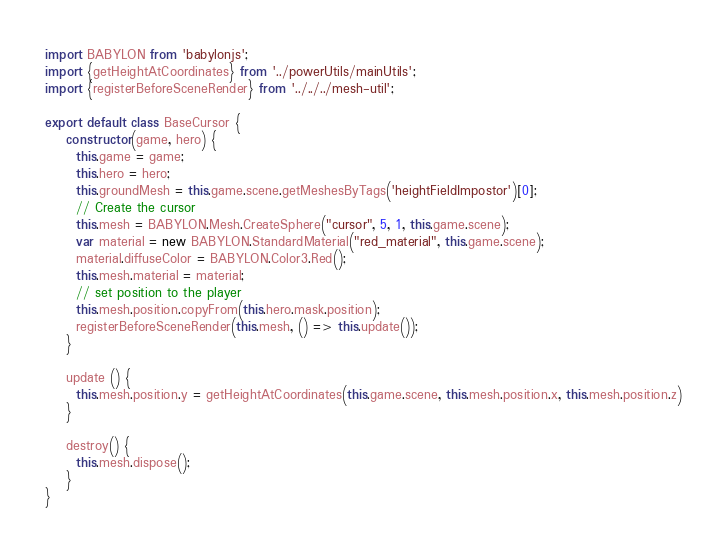Convert code to text. <code><loc_0><loc_0><loc_500><loc_500><_JavaScript_>import BABYLON from 'babylonjs';
import {getHeightAtCoordinates} from '../powerUtils/mainUtils';
import {registerBeforeSceneRender} from '../../../mesh-util';

export default class BaseCursor {
    constructor(game, hero) {
      this.game = game;
      this.hero = hero;
      this.groundMesh = this.game.scene.getMeshesByTags('heightFieldImpostor')[0];
      // Create the cursor
      this.mesh = BABYLON.Mesh.CreateSphere("cursor", 5, 1, this.game.scene);
      var material = new BABYLON.StandardMaterial("red_material", this.game.scene);
      material.diffuseColor = BABYLON.Color3.Red();
      this.mesh.material = material;
      // set position to the player
      this.mesh.position.copyFrom(this.hero.mask.position);
      registerBeforeSceneRender(this.mesh, () => this.update());
    }

    update () {
      this.mesh.position.y = getHeightAtCoordinates(this.game.scene, this.mesh.position.x, this.mesh.position.z)
    }

    destroy() {
      this.mesh.dispose();
    }
}
</code> 